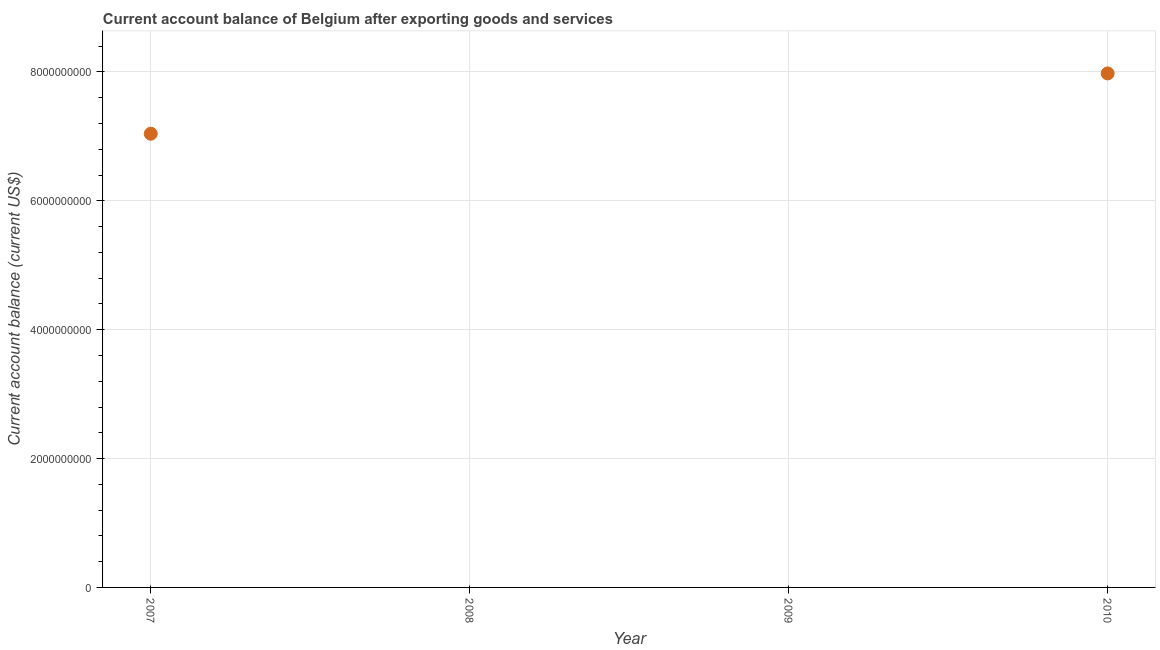What is the current account balance in 2010?
Your answer should be compact. 7.98e+09. Across all years, what is the maximum current account balance?
Offer a terse response. 7.98e+09. Across all years, what is the minimum current account balance?
Provide a short and direct response. 0. In which year was the current account balance maximum?
Offer a very short reply. 2010. What is the sum of the current account balance?
Make the answer very short. 1.50e+1. What is the difference between the current account balance in 2007 and 2010?
Make the answer very short. -9.36e+08. What is the average current account balance per year?
Give a very brief answer. 3.75e+09. What is the median current account balance?
Offer a very short reply. 3.52e+09. In how many years, is the current account balance greater than 400000000 US$?
Your response must be concise. 2. What is the ratio of the current account balance in 2007 to that in 2010?
Your answer should be compact. 0.88. Is the difference between the current account balance in 2007 and 2010 greater than the difference between any two years?
Give a very brief answer. No. What is the difference between the highest and the lowest current account balance?
Your answer should be very brief. 7.98e+09. In how many years, is the current account balance greater than the average current account balance taken over all years?
Offer a terse response. 2. Does the current account balance monotonically increase over the years?
Your response must be concise. No. What is the difference between two consecutive major ticks on the Y-axis?
Offer a terse response. 2.00e+09. Are the values on the major ticks of Y-axis written in scientific E-notation?
Give a very brief answer. No. Does the graph contain grids?
Offer a terse response. Yes. What is the title of the graph?
Offer a very short reply. Current account balance of Belgium after exporting goods and services. What is the label or title of the X-axis?
Make the answer very short. Year. What is the label or title of the Y-axis?
Offer a very short reply. Current account balance (current US$). What is the Current account balance (current US$) in 2007?
Keep it short and to the point. 7.04e+09. What is the Current account balance (current US$) in 2008?
Ensure brevity in your answer.  0. What is the Current account balance (current US$) in 2010?
Give a very brief answer. 7.98e+09. What is the difference between the Current account balance (current US$) in 2007 and 2010?
Provide a short and direct response. -9.36e+08. What is the ratio of the Current account balance (current US$) in 2007 to that in 2010?
Your response must be concise. 0.88. 